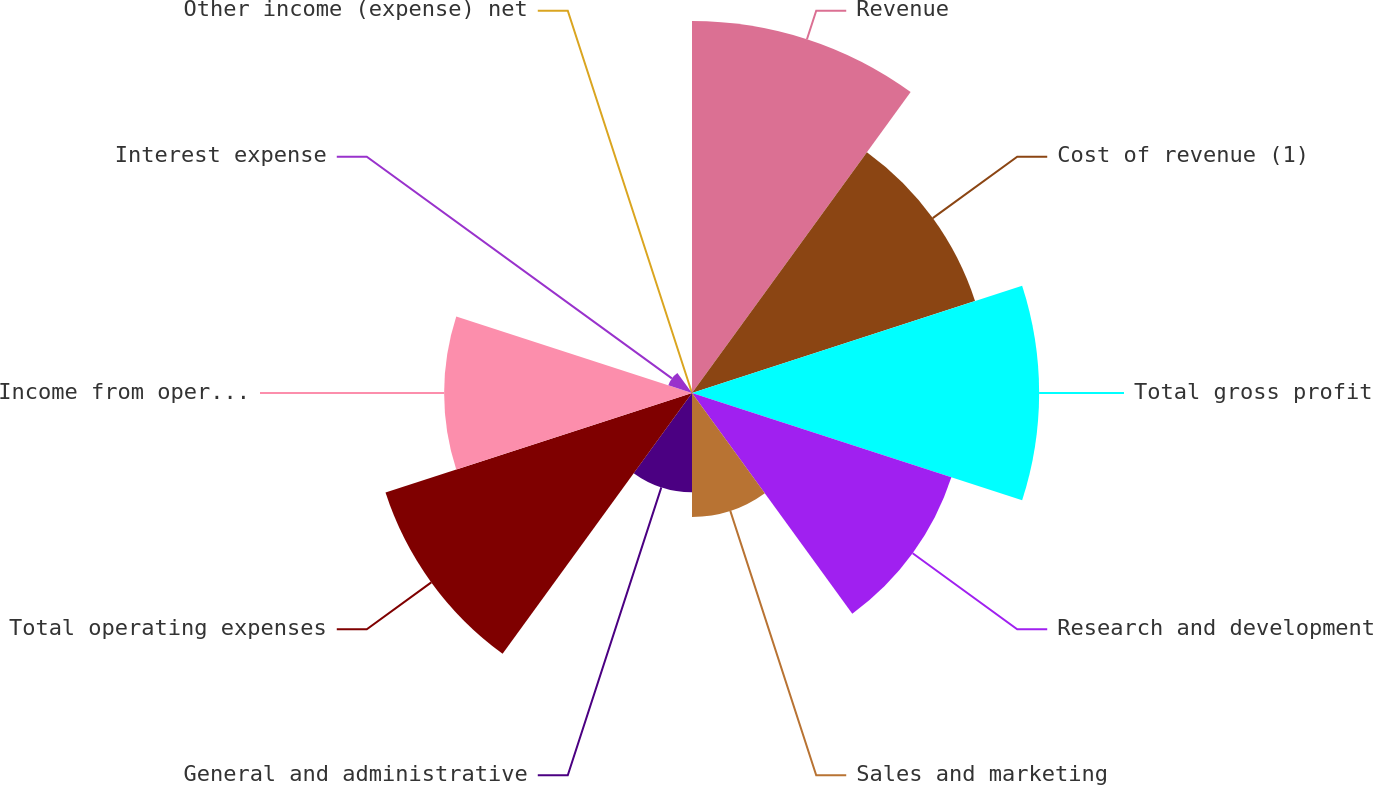Convert chart. <chart><loc_0><loc_0><loc_500><loc_500><pie_chart><fcel>Revenue<fcel>Cost of revenue (1)<fcel>Total gross profit<fcel>Research and development<fcel>Sales and marketing<fcel>General and administrative<fcel>Total operating expenses<fcel>Income from operations<fcel>Interest expense<fcel>Other income (expense) net<nl><fcel>17.65%<fcel>14.12%<fcel>16.47%<fcel>12.94%<fcel>5.88%<fcel>4.71%<fcel>15.29%<fcel>11.76%<fcel>1.18%<fcel>0.0%<nl></chart> 